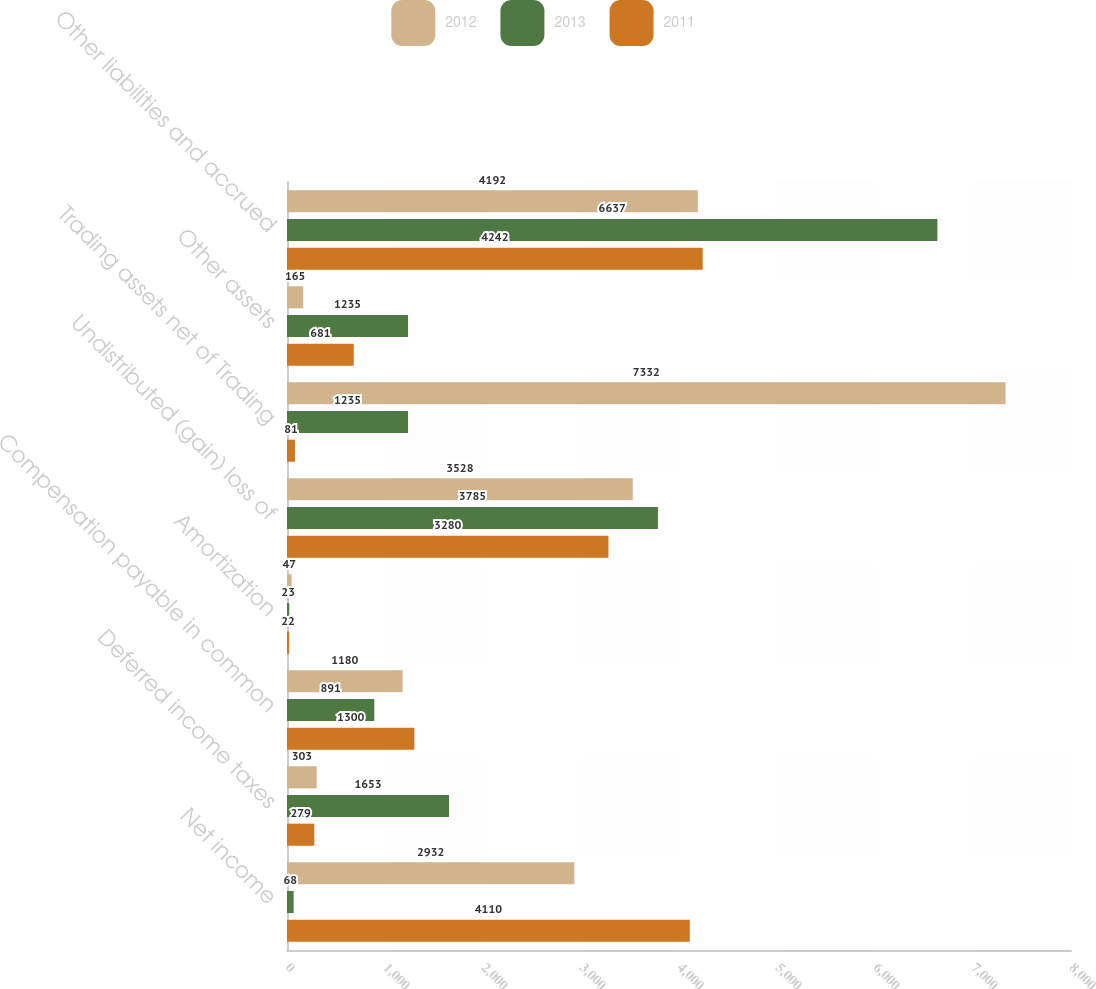Convert chart to OTSL. <chart><loc_0><loc_0><loc_500><loc_500><stacked_bar_chart><ecel><fcel>Net income<fcel>Deferred income taxes<fcel>Compensation payable in common<fcel>Amortization<fcel>Undistributed (gain) loss of<fcel>Trading assets net of Trading<fcel>Other assets<fcel>Other liabilities and accrued<nl><fcel>2012<fcel>2932<fcel>303<fcel>1180<fcel>47<fcel>3528<fcel>7332<fcel>165<fcel>4192<nl><fcel>2013<fcel>68<fcel>1653<fcel>891<fcel>23<fcel>3785<fcel>1235<fcel>1235<fcel>6637<nl><fcel>2011<fcel>4110<fcel>279<fcel>1300<fcel>22<fcel>3280<fcel>81<fcel>681<fcel>4242<nl></chart> 